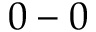Convert formula to latex. <formula><loc_0><loc_0><loc_500><loc_500>0 - 0</formula> 